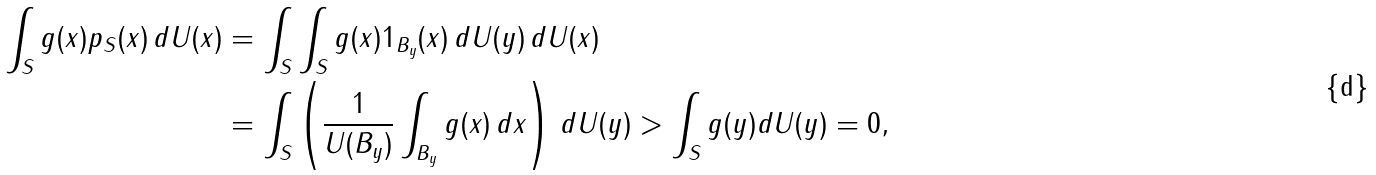Convert formula to latex. <formula><loc_0><loc_0><loc_500><loc_500>\int _ { S } g ( x ) p _ { S } ( x ) \, d U ( x ) & = \int _ { S } \int _ { S } g ( x ) 1 _ { B _ { y } } ( x ) \, d U ( y ) \, d U ( x ) \\ & = \int _ { S } \left ( \frac { 1 } { U ( B _ { y } ) } \int _ { B _ { y } } g ( x ) \, d x \right ) \, d U ( y ) > \int _ { S } g ( y ) d U ( y ) = 0 ,</formula> 